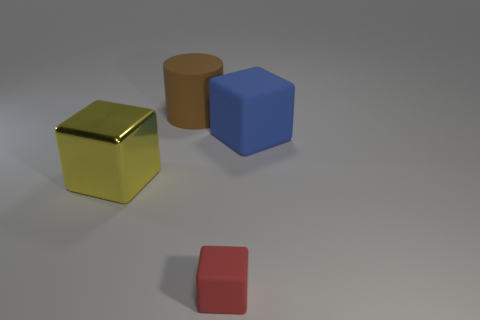Add 2 large blocks. How many objects exist? 6 Subtract all blocks. How many objects are left? 1 Add 4 tiny purple matte spheres. How many tiny purple matte spheres exist? 4 Subtract 0 cyan spheres. How many objects are left? 4 Subtract all large brown rubber cylinders. Subtract all large cyan metal cylinders. How many objects are left? 3 Add 1 big yellow blocks. How many big yellow blocks are left? 2 